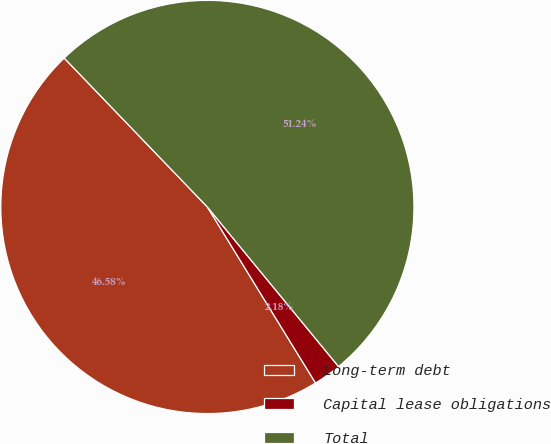Convert chart. <chart><loc_0><loc_0><loc_500><loc_500><pie_chart><fcel>Long-term debt<fcel>Capital lease obligations<fcel>Total<nl><fcel>46.58%<fcel>2.18%<fcel>51.24%<nl></chart> 